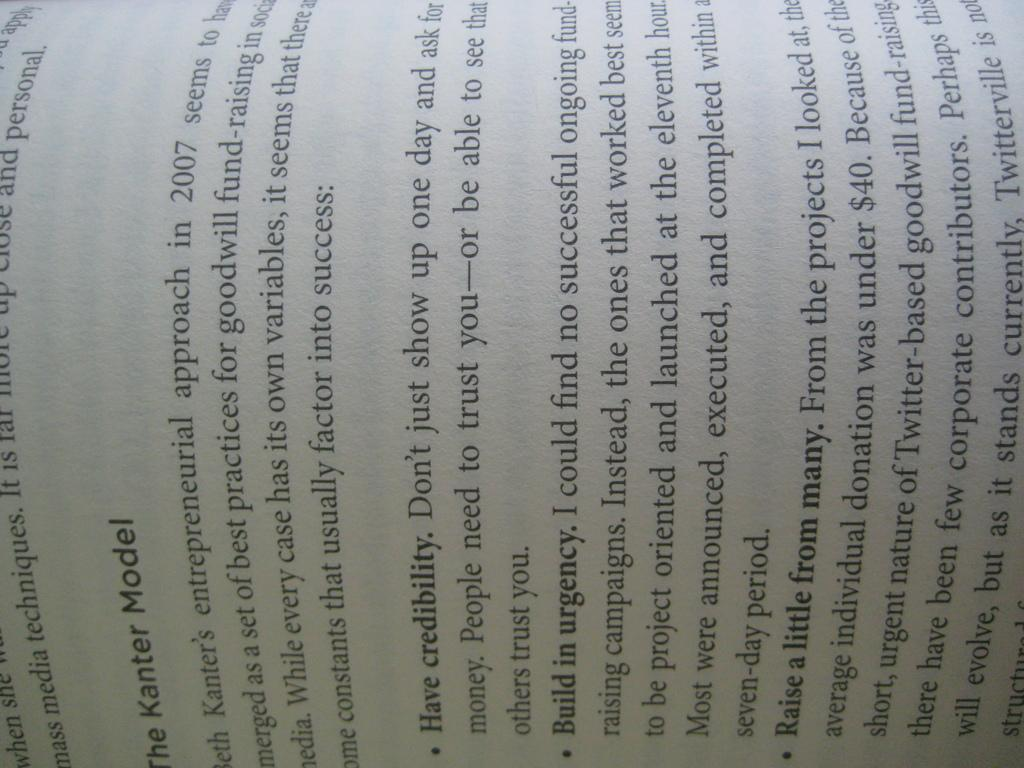<image>
Relay a brief, clear account of the picture shown. The Kanter Model chapter in a book about credibility and building in urgency. 